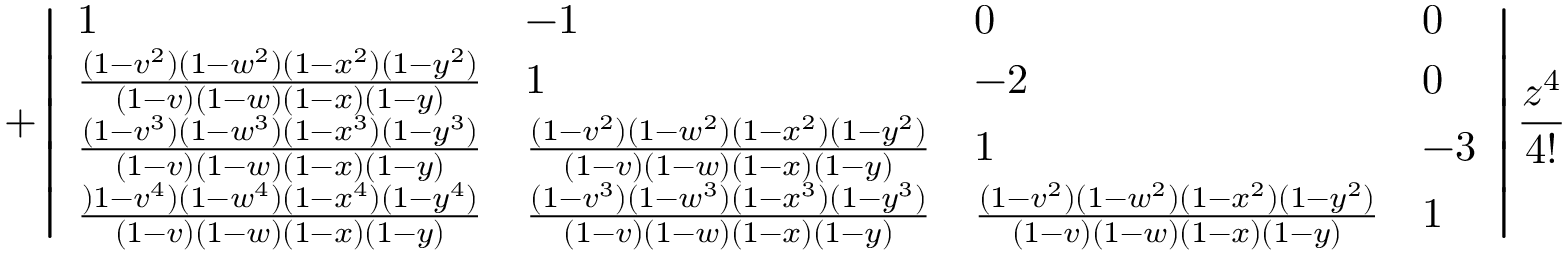Convert formula to latex. <formula><loc_0><loc_0><loc_500><loc_500>+ \left | \begin{array} { l l l l } { 1 } & { - 1 } & { 0 } & { 0 } \\ { \frac { ( 1 - v ^ { 2 } ) ( 1 - w ^ { 2 } ) ( 1 - x ^ { 2 } ) ( 1 - y ^ { 2 } ) } { ( 1 - v ) ( 1 - w ) ( 1 - x ) ( 1 - y ) } } & { 1 } & { - 2 } & { 0 } \\ { \frac { ( 1 - v ^ { 3 } ) ( 1 - w ^ { 3 } ) ( 1 - x ^ { 3 } ) ( 1 - y ^ { 3 } ) } { ( 1 - v ) ( 1 - w ) ( 1 - x ) ( 1 - y ) } } & { \frac { ( 1 - v ^ { 2 } ) ( 1 - w ^ { 2 } ) ( 1 - x ^ { 2 } ) ( 1 - y ^ { 2 } ) } { ( 1 - v ) ( 1 - w ) ( 1 - x ) ( 1 - y ) } } & { 1 } & { - 3 } \\ { \frac { ) 1 - v ^ { 4 } ) ( 1 - w ^ { 4 } ) ( 1 - x ^ { 4 } ) ( 1 - y ^ { 4 } ) } { ( 1 - v ) ( 1 - w ) ( 1 - x ) ( 1 - y ) } } & { \frac { ( 1 - v ^ { 3 } ) ( 1 - w ^ { 3 } ) ( 1 - x ^ { 3 } ) ( 1 - y ^ { 3 } ) } { ( 1 - v ) ( 1 - w ) ( 1 - x ) ( 1 - y ) } } & { \frac { ( 1 - v ^ { 2 } ) ( 1 - w ^ { 2 } ) ( 1 - x ^ { 2 } ) ( 1 - y ^ { 2 } ) } { ( 1 - v ) ( 1 - w ) ( 1 - x ) ( 1 - y ) } } & { 1 } \end{array} \right | \frac { z ^ { 4 } } { 4 ! }</formula> 